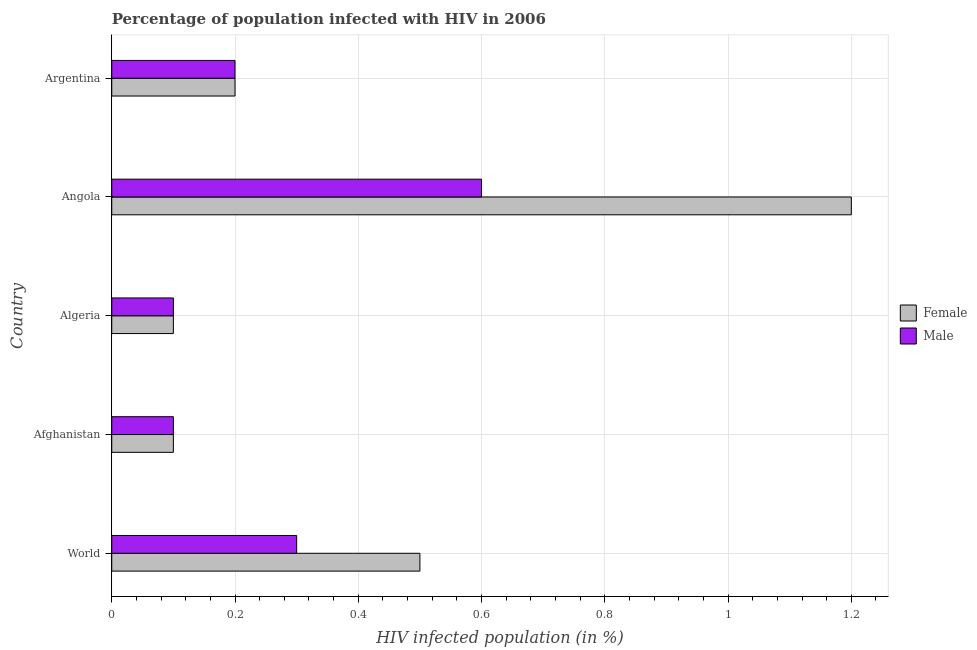How many groups of bars are there?
Your answer should be very brief. 5. Are the number of bars on each tick of the Y-axis equal?
Ensure brevity in your answer.  Yes. How many bars are there on the 2nd tick from the top?
Provide a short and direct response. 2. What is the label of the 3rd group of bars from the top?
Offer a terse response. Algeria. In which country was the percentage of males who are infected with hiv maximum?
Ensure brevity in your answer.  Angola. In which country was the percentage of males who are infected with hiv minimum?
Provide a short and direct response. Afghanistan. What is the total percentage of females who are infected with hiv in the graph?
Provide a succinct answer. 2.1. What is the difference between the percentage of males who are infected with hiv in Angola and the percentage of females who are infected with hiv in Afghanistan?
Offer a terse response. 0.5. What is the average percentage of females who are infected with hiv per country?
Keep it short and to the point. 0.42. In how many countries, is the percentage of males who are infected with hiv greater than 1 %?
Make the answer very short. 0. What is the ratio of the percentage of males who are infected with hiv in Algeria to that in World?
Make the answer very short. 0.33. Is the difference between the percentage of males who are infected with hiv in Afghanistan and World greater than the difference between the percentage of females who are infected with hiv in Afghanistan and World?
Keep it short and to the point. Yes. What is the difference between the highest and the lowest percentage of males who are infected with hiv?
Offer a very short reply. 0.5. In how many countries, is the percentage of males who are infected with hiv greater than the average percentage of males who are infected with hiv taken over all countries?
Give a very brief answer. 2. Is the sum of the percentage of females who are infected with hiv in Afghanistan and Argentina greater than the maximum percentage of males who are infected with hiv across all countries?
Your response must be concise. No. What does the 2nd bar from the top in Afghanistan represents?
Your answer should be very brief. Female. Are all the bars in the graph horizontal?
Give a very brief answer. Yes. Does the graph contain grids?
Ensure brevity in your answer.  Yes. How are the legend labels stacked?
Keep it short and to the point. Vertical. What is the title of the graph?
Offer a terse response. Percentage of population infected with HIV in 2006. Does "Age 65(male)" appear as one of the legend labels in the graph?
Make the answer very short. No. What is the label or title of the X-axis?
Give a very brief answer. HIV infected population (in %). What is the label or title of the Y-axis?
Offer a very short reply. Country. What is the HIV infected population (in %) of Female in World?
Keep it short and to the point. 0.5. What is the HIV infected population (in %) in Male in World?
Give a very brief answer. 0.3. What is the HIV infected population (in %) of Female in Afghanistan?
Offer a terse response. 0.1. What is the HIV infected population (in %) in Male in Afghanistan?
Make the answer very short. 0.1. What is the HIV infected population (in %) of Male in Angola?
Your response must be concise. 0.6. What is the HIV infected population (in %) of Female in Argentina?
Ensure brevity in your answer.  0.2. What is the HIV infected population (in %) in Male in Argentina?
Make the answer very short. 0.2. Across all countries, what is the maximum HIV infected population (in %) of Female?
Your response must be concise. 1.2. Across all countries, what is the minimum HIV infected population (in %) in Female?
Your answer should be compact. 0.1. What is the total HIV infected population (in %) of Female in the graph?
Give a very brief answer. 2.1. What is the total HIV infected population (in %) in Male in the graph?
Your answer should be compact. 1.3. What is the difference between the HIV infected population (in %) of Female in World and that in Afghanistan?
Offer a very short reply. 0.4. What is the difference between the HIV infected population (in %) in Male in World and that in Angola?
Keep it short and to the point. -0.3. What is the difference between the HIV infected population (in %) in Male in World and that in Argentina?
Keep it short and to the point. 0.1. What is the difference between the HIV infected population (in %) in Female in Afghanistan and that in Algeria?
Offer a very short reply. 0. What is the difference between the HIV infected population (in %) in Male in Afghanistan and that in Algeria?
Offer a terse response. 0. What is the difference between the HIV infected population (in %) of Male in Afghanistan and that in Angola?
Your answer should be compact. -0.5. What is the difference between the HIV infected population (in %) of Male in Algeria and that in Angola?
Offer a very short reply. -0.5. What is the difference between the HIV infected population (in %) in Female in Algeria and that in Argentina?
Offer a terse response. -0.1. What is the difference between the HIV infected population (in %) in Female in World and the HIV infected population (in %) in Male in Afghanistan?
Offer a very short reply. 0.4. What is the difference between the HIV infected population (in %) in Female in World and the HIV infected population (in %) in Male in Angola?
Ensure brevity in your answer.  -0.1. What is the difference between the HIV infected population (in %) of Female in Afghanistan and the HIV infected population (in %) of Male in Algeria?
Keep it short and to the point. 0. What is the difference between the HIV infected population (in %) of Female in Afghanistan and the HIV infected population (in %) of Male in Argentina?
Make the answer very short. -0.1. What is the difference between the HIV infected population (in %) in Female in Angola and the HIV infected population (in %) in Male in Argentina?
Ensure brevity in your answer.  1. What is the average HIV infected population (in %) of Female per country?
Your answer should be very brief. 0.42. What is the average HIV infected population (in %) of Male per country?
Keep it short and to the point. 0.26. What is the difference between the HIV infected population (in %) of Female and HIV infected population (in %) of Male in World?
Ensure brevity in your answer.  0.2. What is the difference between the HIV infected population (in %) in Female and HIV infected population (in %) in Male in Algeria?
Give a very brief answer. 0. What is the difference between the HIV infected population (in %) of Female and HIV infected population (in %) of Male in Argentina?
Offer a terse response. 0. What is the ratio of the HIV infected population (in %) in Female in World to that in Angola?
Make the answer very short. 0.42. What is the ratio of the HIV infected population (in %) of Male in Afghanistan to that in Algeria?
Your response must be concise. 1. What is the ratio of the HIV infected population (in %) of Female in Afghanistan to that in Angola?
Your answer should be compact. 0.08. What is the ratio of the HIV infected population (in %) in Male in Afghanistan to that in Angola?
Provide a succinct answer. 0.17. What is the ratio of the HIV infected population (in %) in Female in Afghanistan to that in Argentina?
Give a very brief answer. 0.5. What is the ratio of the HIV infected population (in %) of Female in Algeria to that in Angola?
Provide a succinct answer. 0.08. What is the ratio of the HIV infected population (in %) of Male in Angola to that in Argentina?
Make the answer very short. 3. What is the difference between the highest and the second highest HIV infected population (in %) in Male?
Give a very brief answer. 0.3. 